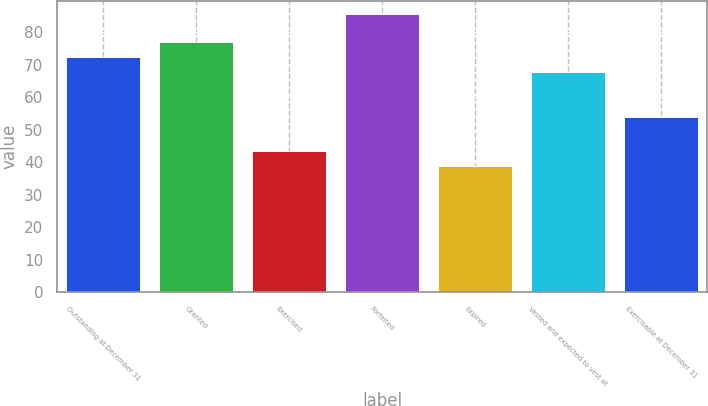<chart> <loc_0><loc_0><loc_500><loc_500><bar_chart><fcel>Outstanding at December 31<fcel>Granted<fcel>Exercised<fcel>Forfeited<fcel>Expired<fcel>Vested and expected to vest at<fcel>Exercisable at December 31<nl><fcel>72.42<fcel>77.08<fcel>43.48<fcel>85.41<fcel>38.82<fcel>67.76<fcel>53.78<nl></chart> 